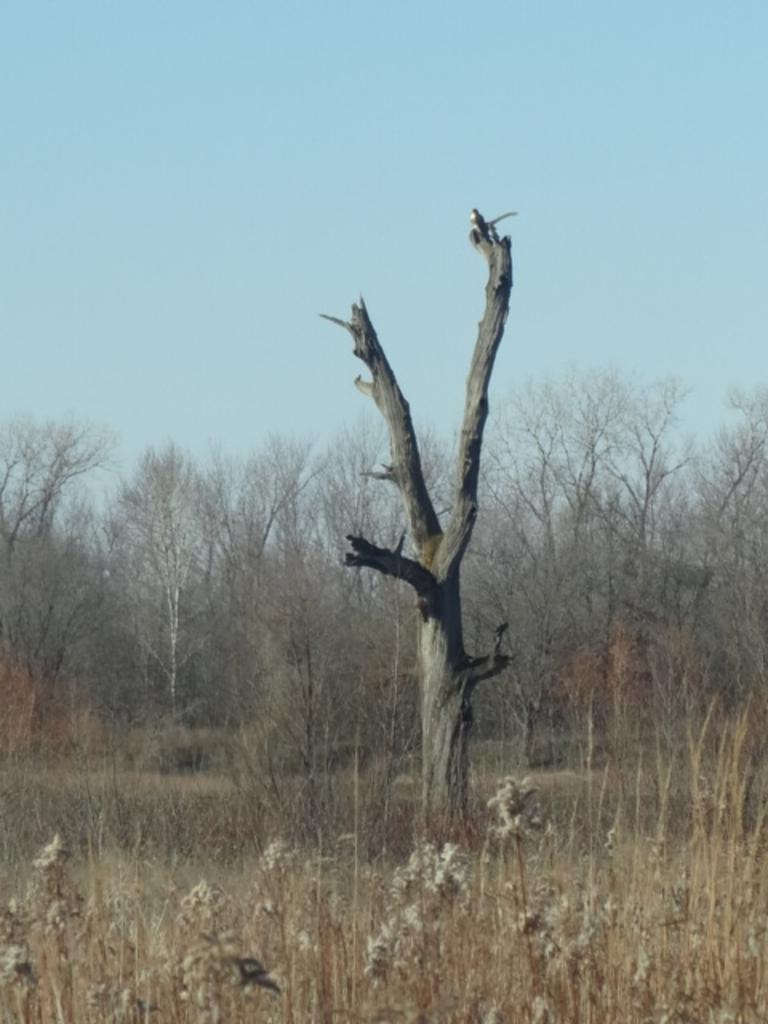What is located in the foreground of the picture? There are plants in the foreground of the picture. What can be seen in the center of the picture? The trunk of a tree is visible in the center of the picture. What is visible in the background of the picture? There are trees and plants in the background of the picture. What is visible at the top of the image? The sky is visible at the top of the image. What type of ticket is required to enter the religious place depicted in the image? There is no religious place or ticket present in the image; it features plants, trees, and the sky. What type of place is depicted in the image? The image does not depict a specific place; it features plants, trees, and the sky. 